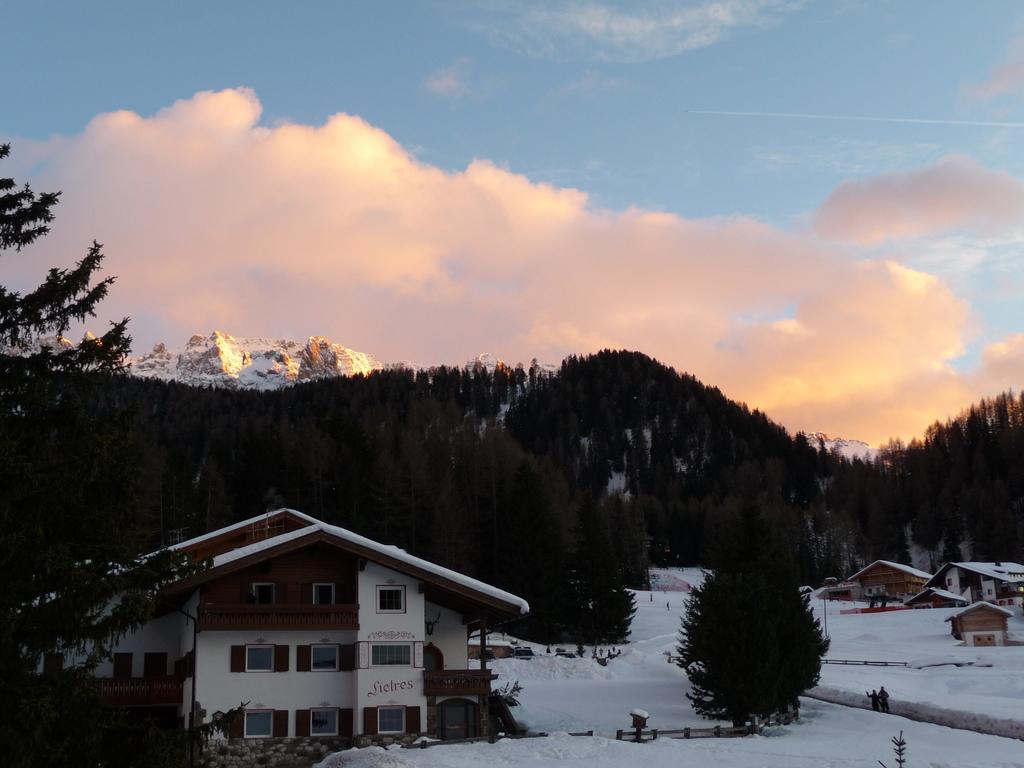Could you give a brief overview of what you see in this image? In this picture we can see buildings with windows, snow, trees, mountains and two people standing and in the background we can see the sky with clouds. 